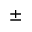Convert formula to latex. <formula><loc_0><loc_0><loc_500><loc_500>\pm</formula> 